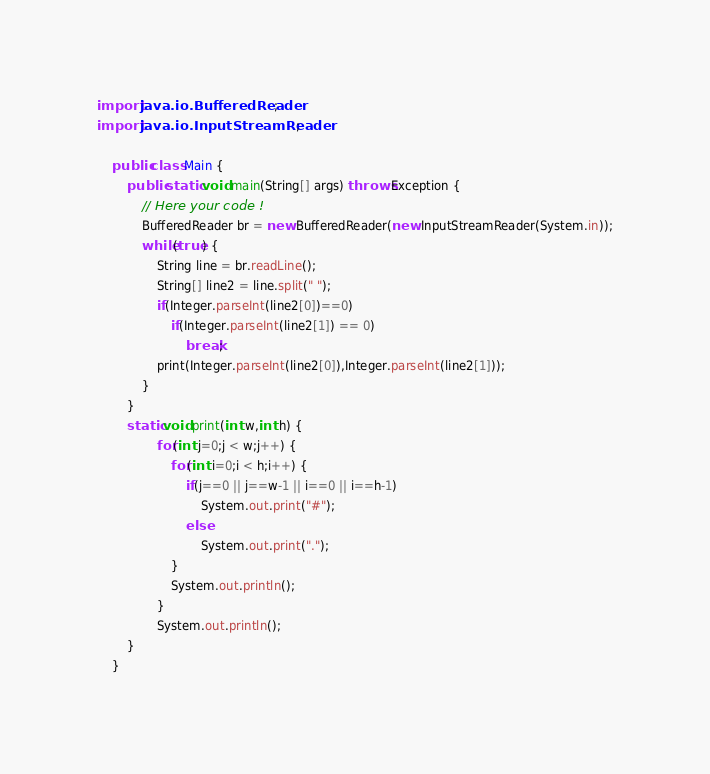<code> <loc_0><loc_0><loc_500><loc_500><_Java_>import java.io.BufferedReader;
import java.io.InputStreamReader;

	public class Main {
	    public static void main(String[] args) throws Exception {
	        // Here your code !
	        BufferedReader br = new BufferedReader(new InputStreamReader(System.in));
	        while(true) {
		        String line = br.readLine();
		        String[] line2 = line.split(" ");
		        if(Integer.parseInt(line2[0])==0)
		        	if(Integer.parseInt(line2[1]) == 0)
		        		break;
		        print(Integer.parseInt(line2[0]),Integer.parseInt(line2[1]));
	        }
	    }
	    static void print(int w,int h) {
	    		for(int j=0;j < w;j++) {
	    	    	for(int i=0;i < h;i++) {
	    	    	    if(j==0 || j==w-1 || i==0 || i==h-1)
    	    	    		System.out.print("#");
    	    	    	else
    	    	    		System.out.print(".");
	    	    	}
		    		System.out.println();
	    		}
	    		System.out.println();
	    }
	}</code> 